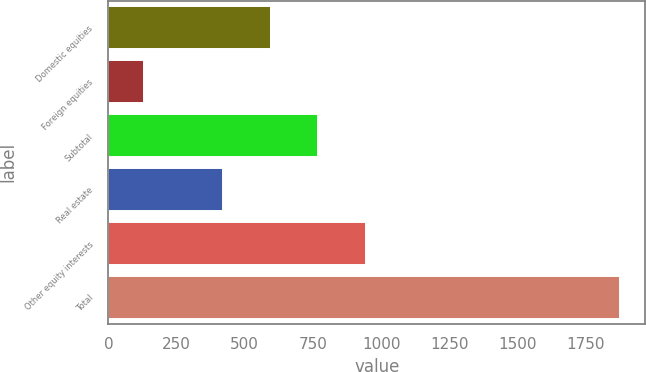<chart> <loc_0><loc_0><loc_500><loc_500><bar_chart><fcel>Domestic equities<fcel>Foreign equities<fcel>Subtotal<fcel>Real estate<fcel>Other equity interests<fcel>Total<nl><fcel>595.4<fcel>131<fcel>769.8<fcel>421<fcel>944.2<fcel>1875<nl></chart> 